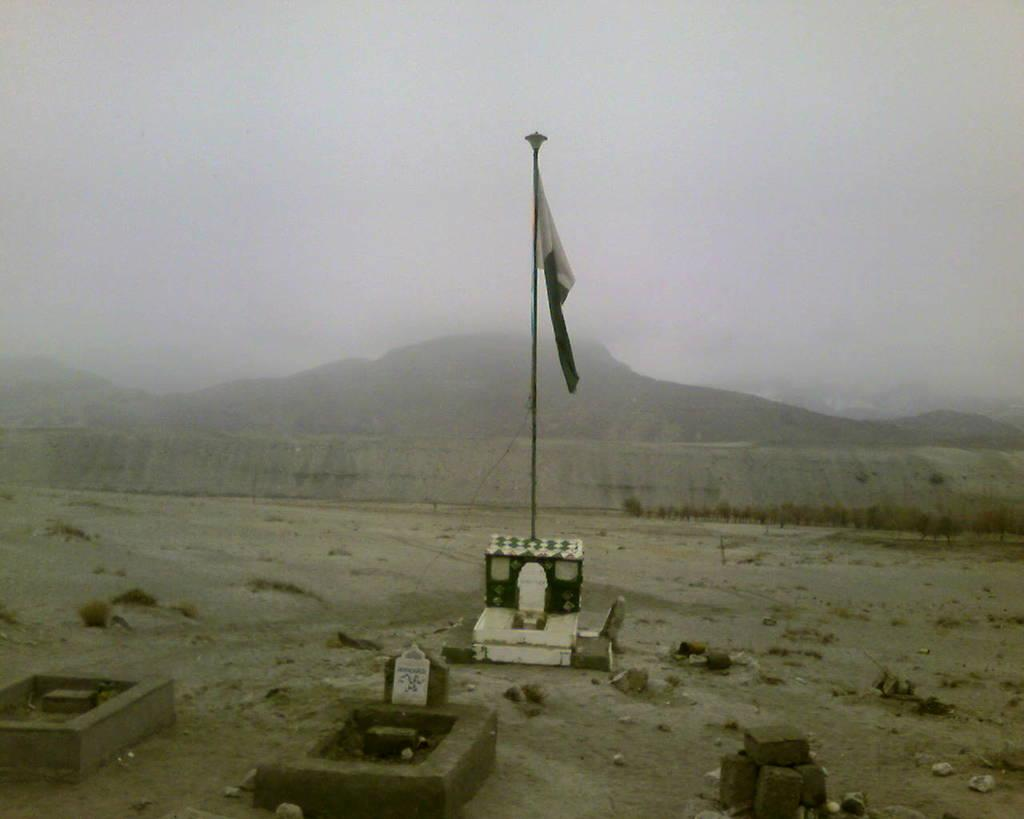What is on the pedestal in the image? There is a flag on a pedestal in the image. What objects are near the pedestal? There are blocks near the pedestal. What can be seen on the ground in the image? There are stones on the ground in the image. What is visible in the background of the image? There is a wall, hills, and the sky visible in the background of the image. What type of watch is the expert wearing in the image? There is no expert or watch present in the image; it features a flag on a pedestal, blocks, stones, a wall, hills, and the sky. 